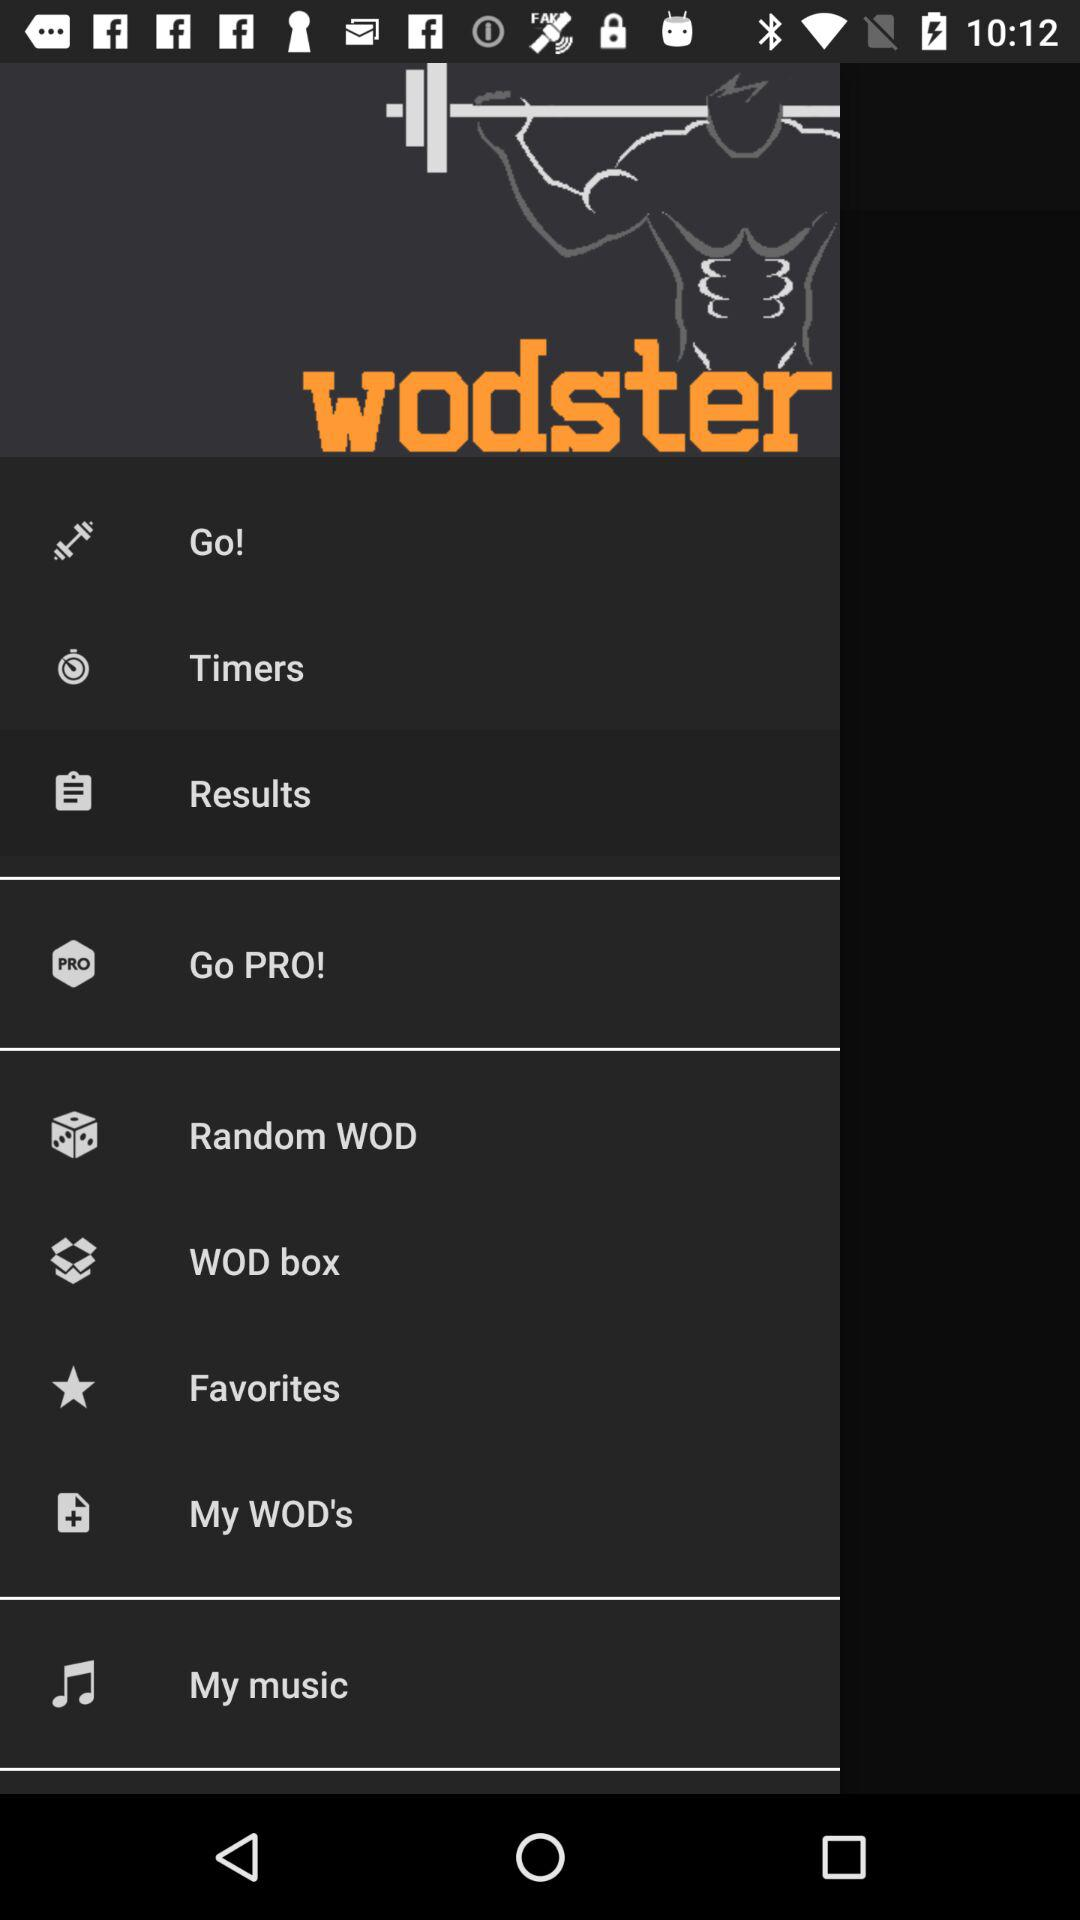What is the name of the application? The name of the application is "wodster". 